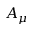Convert formula to latex. <formula><loc_0><loc_0><loc_500><loc_500>A _ { \mu }</formula> 